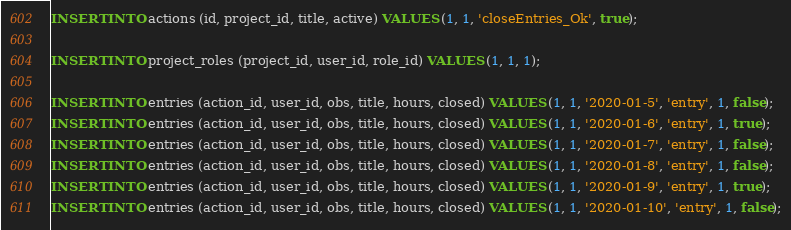<code> <loc_0><loc_0><loc_500><loc_500><_SQL_>INSERT INTO actions (id, project_id, title, active) VALUES (1, 1, 'closeEntries_Ok', true);

INSERT INTO project_roles (project_id, user_id, role_id) VALUES (1, 1, 1);

INSERT INTO entries (action_id, user_id, obs, title, hours, closed) VALUES (1, 1, '2020-01-5', 'entry', 1, false);
INSERT INTO entries (action_id, user_id, obs, title, hours, closed) VALUES (1, 1, '2020-01-6', 'entry', 1, true);
INSERT INTO entries (action_id, user_id, obs, title, hours, closed) VALUES (1, 1, '2020-01-7', 'entry', 1, false);
INSERT INTO entries (action_id, user_id, obs, title, hours, closed) VALUES (1, 1, '2020-01-8', 'entry', 1, false);
INSERT INTO entries (action_id, user_id, obs, title, hours, closed) VALUES (1, 1, '2020-01-9', 'entry', 1, true);
INSERT INTO entries (action_id, user_id, obs, title, hours, closed) VALUES (1, 1, '2020-01-10', 'entry', 1, false);
</code> 